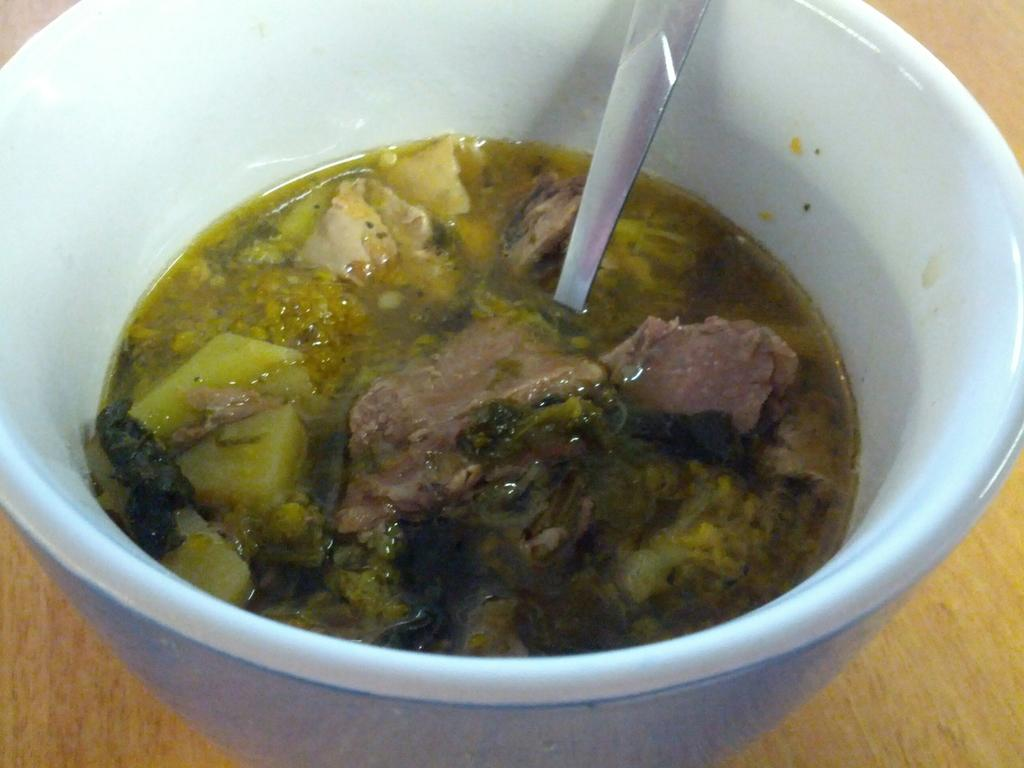What color is the bowl that is on the table in the image? The bowl on the table is white. What is inside the white bowl? There is food in the white bowl. What utensil is present in the white bowl? There is a spoon in the white bowl. What type of potato is being served in the white bowl? There is no potato present in the image; the food in the white bowl is not specified. 